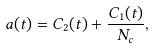Convert formula to latex. <formula><loc_0><loc_0><loc_500><loc_500>a ( t ) = C _ { 2 } ( t ) + \frac { C _ { 1 } ( t ) } { N _ { c } } ,</formula> 